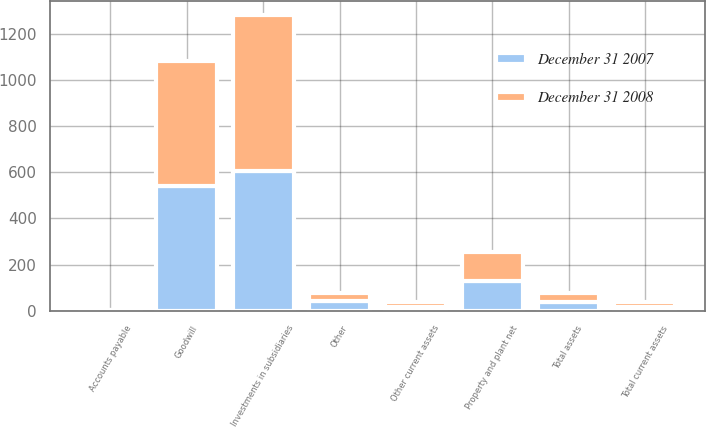<chart> <loc_0><loc_0><loc_500><loc_500><stacked_bar_chart><ecel><fcel>Other current assets<fcel>Total current assets<fcel>Investments in subsidiaries<fcel>Property and plant net<fcel>Goodwill<fcel>Other<fcel>Total assets<fcel>Accounts payable<nl><fcel>December 31 2008<fcel>21<fcel>21<fcel>674<fcel>123<fcel>542<fcel>35<fcel>37.5<fcel>1<nl><fcel>December 31 2007<fcel>16<fcel>16<fcel>606<fcel>130<fcel>542<fcel>40<fcel>37.5<fcel>1<nl></chart> 